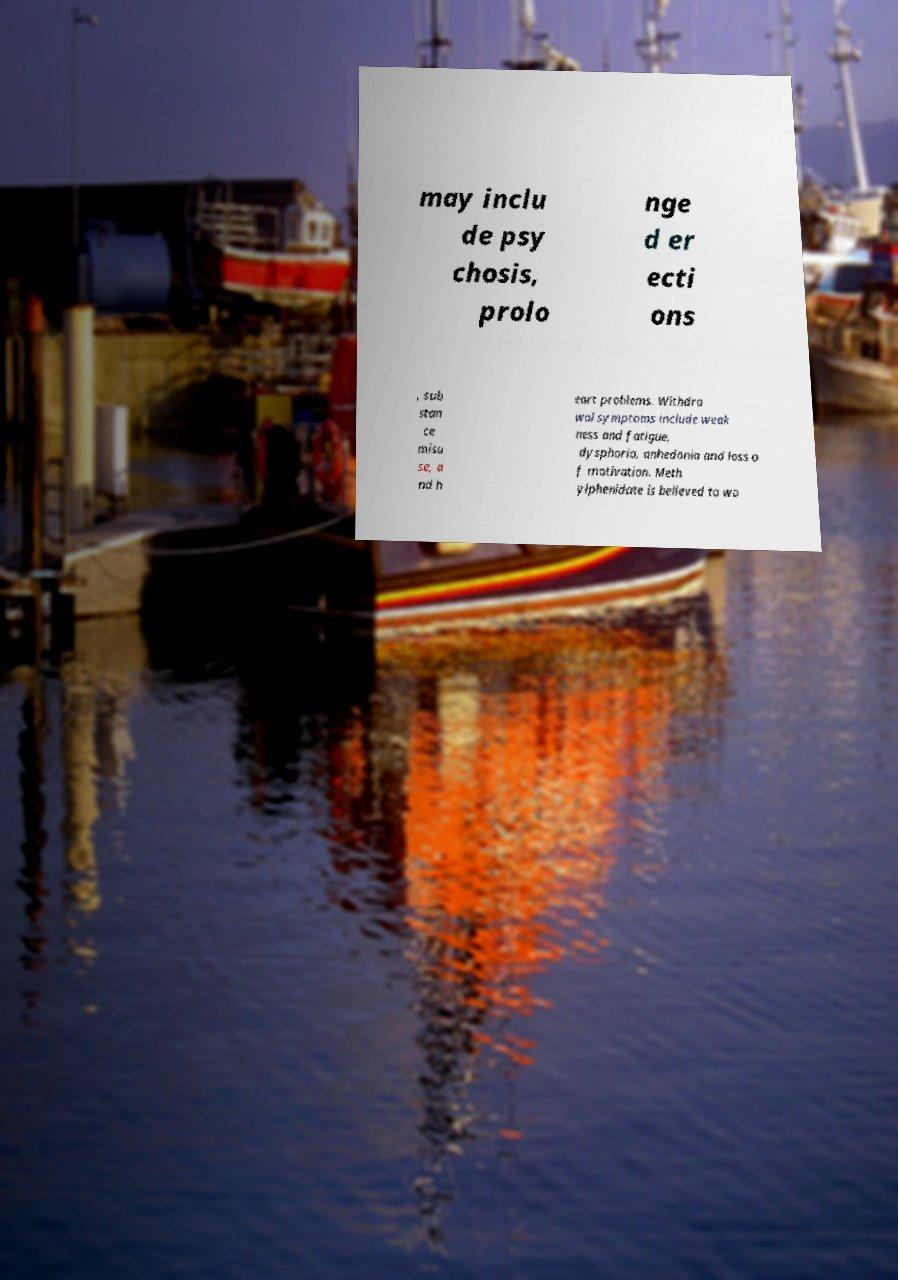Can you accurately transcribe the text from the provided image for me? may inclu de psy chosis, prolo nge d er ecti ons , sub stan ce misu se, a nd h eart problems. Withdra wal symptoms include weak ness and fatigue, dysphoria, anhedonia and loss o f motivation. Meth ylphenidate is believed to wo 